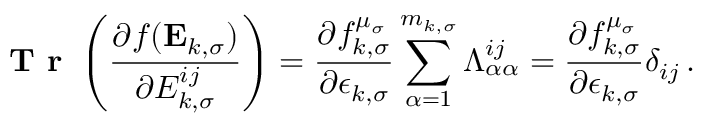Convert formula to latex. <formula><loc_0><loc_0><loc_500><loc_500>T r \left ( \frac { \partial f ( E _ { k , \sigma } ) } { \partial { E } _ { k , \sigma } ^ { i j } } \right ) = \frac { \partial f _ { k , \sigma } ^ { \mu _ { \sigma } } } { \partial \epsilon _ { k , \sigma } } \sum _ { \alpha = 1 } ^ { m _ { k , \sigma } } \Lambda _ { \alpha \alpha } ^ { i j } = \frac { \partial f _ { k , \sigma } ^ { \mu _ { \sigma } } } { \partial \epsilon _ { k , \sigma } } \delta _ { i j } \, .</formula> 